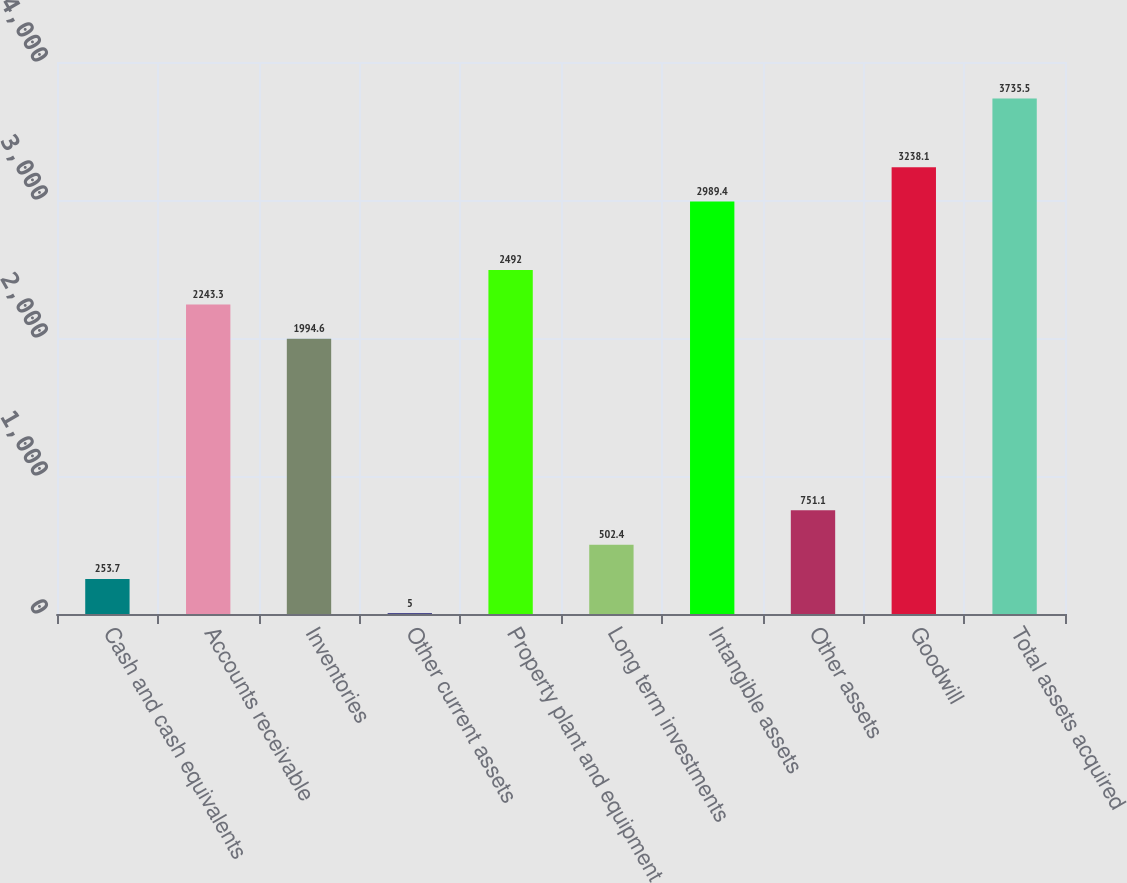<chart> <loc_0><loc_0><loc_500><loc_500><bar_chart><fcel>Cash and cash equivalents<fcel>Accounts receivable<fcel>Inventories<fcel>Other current assets<fcel>Property plant and equipment<fcel>Long term investments<fcel>Intangible assets<fcel>Other assets<fcel>Goodwill<fcel>Total assets acquired<nl><fcel>253.7<fcel>2243.3<fcel>1994.6<fcel>5<fcel>2492<fcel>502.4<fcel>2989.4<fcel>751.1<fcel>3238.1<fcel>3735.5<nl></chart> 